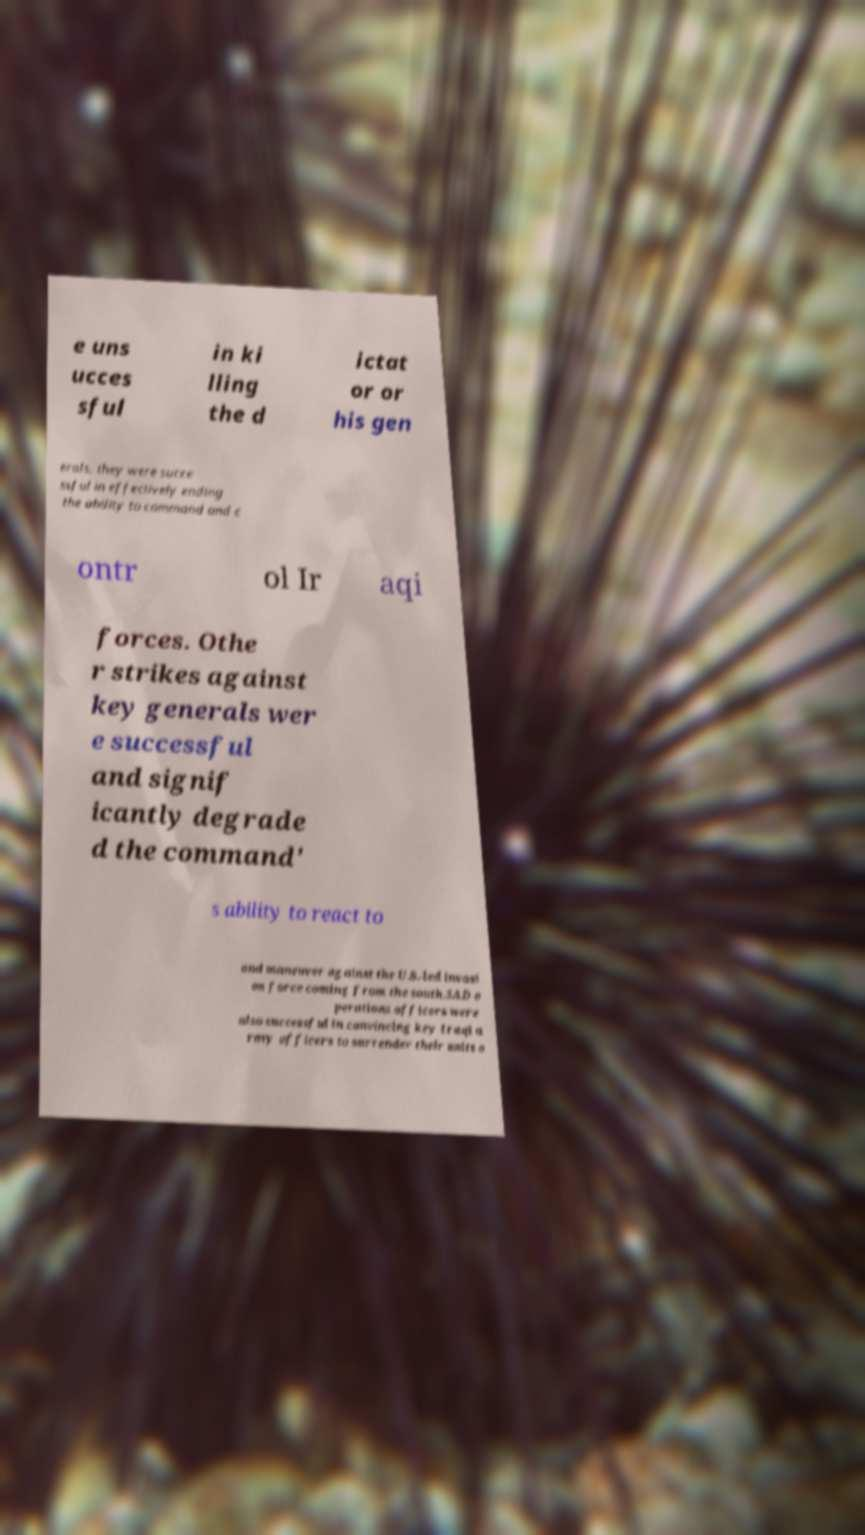Please read and relay the text visible in this image. What does it say? e uns ucces sful in ki lling the d ictat or or his gen erals, they were succe ssful in effectively ending the ability to command and c ontr ol Ir aqi forces. Othe r strikes against key generals wer e successful and signif icantly degrade d the command' s ability to react to and maneuver against the U.S.-led invasi on force coming from the south.SAD o perations officers were also successful in convincing key Iraqi a rmy officers to surrender their units o 